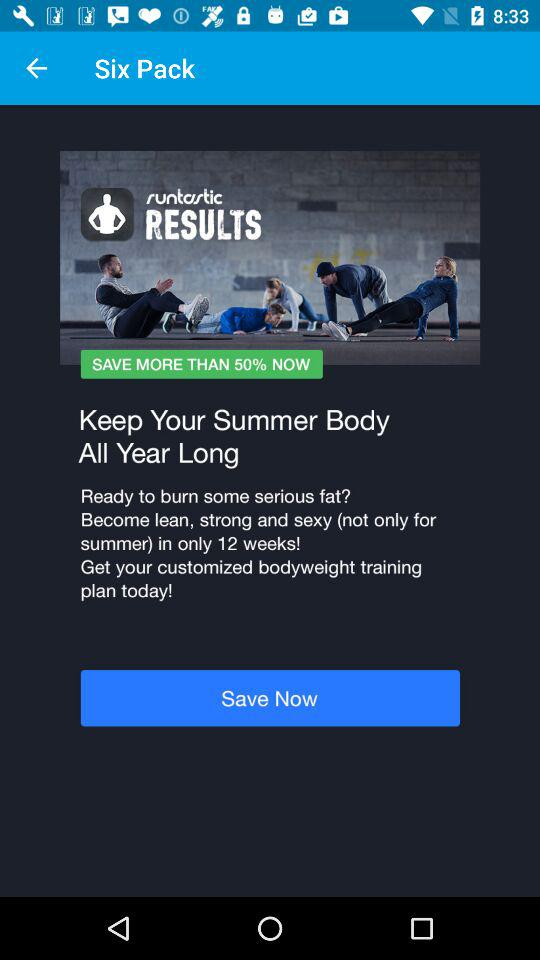How much can I save? You can save more than 50%. 